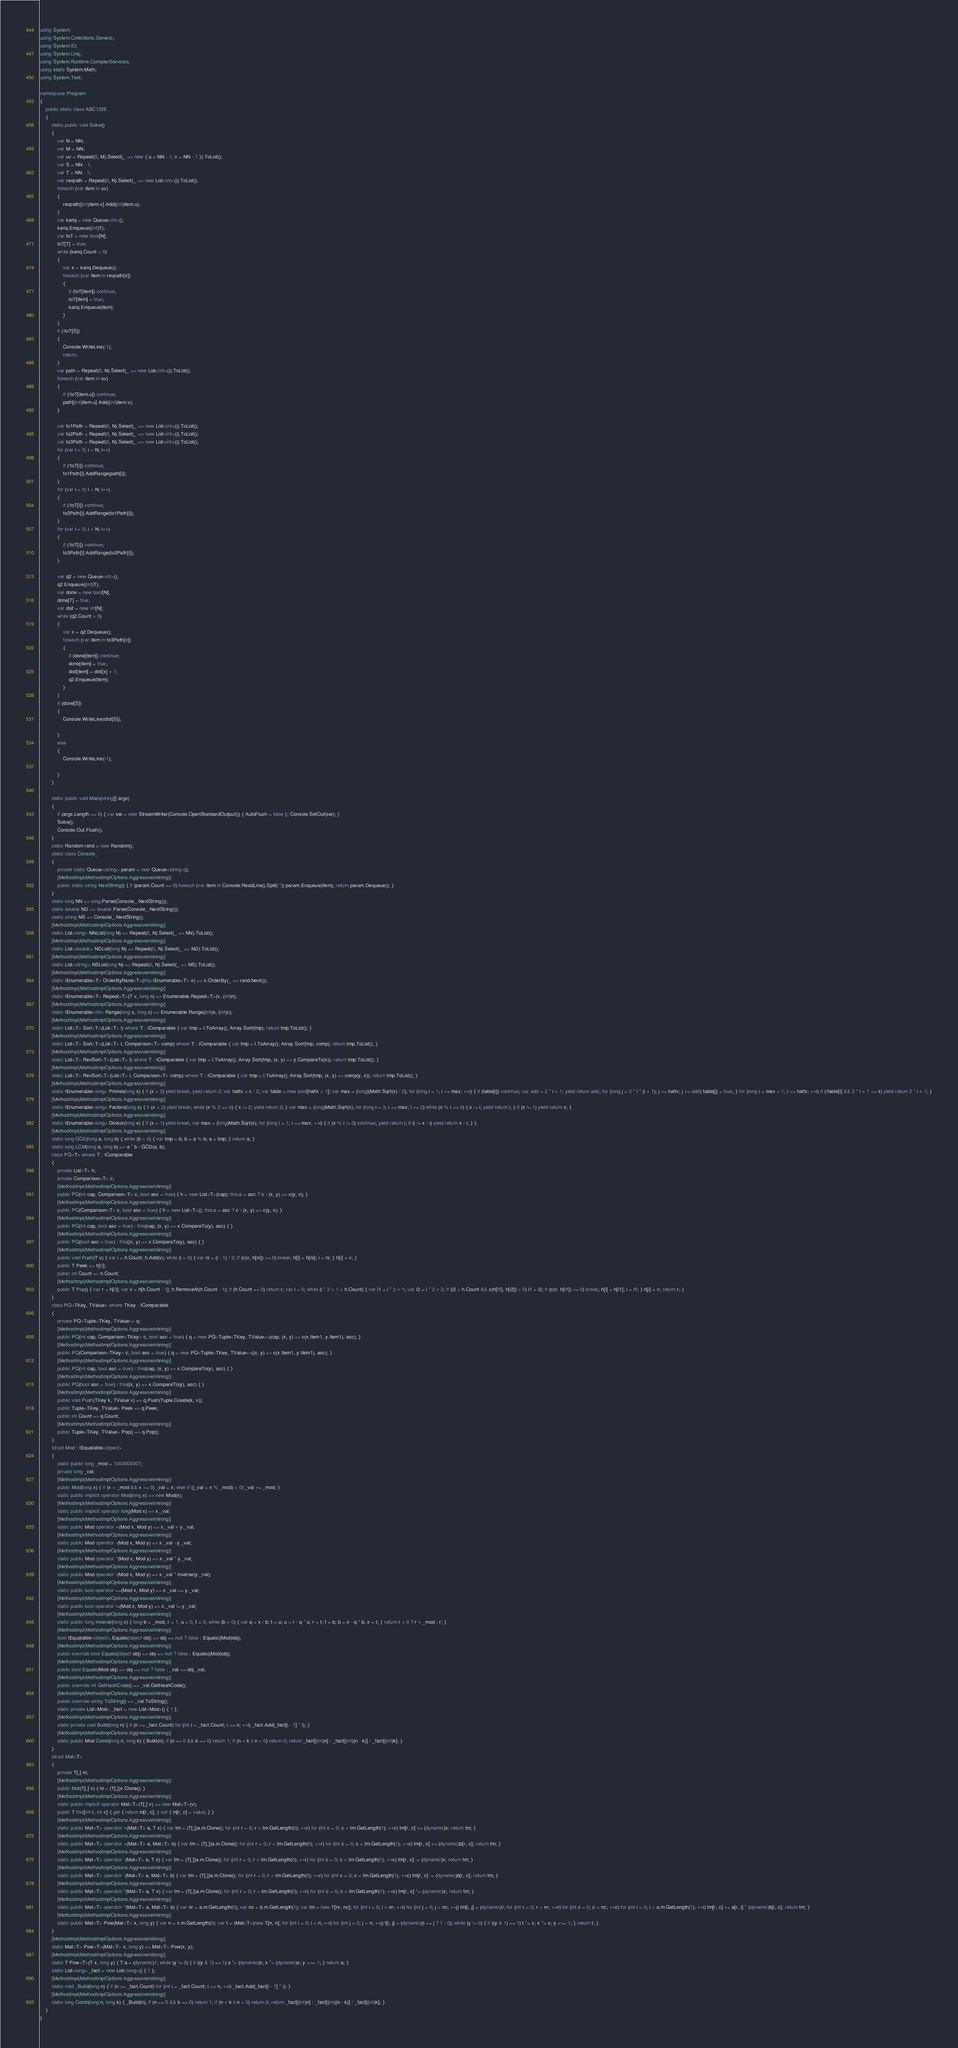<code> <loc_0><loc_0><loc_500><loc_500><_C#_>using System;
using System.Collections.Generic;
using System.IO;
using System.Linq;
using System.Runtime.CompilerServices;
using static System.Math;
using System.Text;

namespace Program
{
    public static class ABC132E
    {
        static public void Solve()
        {
            var N = NN;
            var M = NN;
            var uv = Repeat(0, M).Select(_ => new { u = NN - 1, v = NN - 1 }).ToList();
            var S = NN - 1;
            var T = NN - 1;
            var revpath = Repeat(0, N).Select(_ => new List<int>()).ToList();
            foreach (var item in uv)
            {
                revpath[(int)item.v].Add((int)item.u);
            }
            var kariq = new Queue<int>();
            kariq.Enqueue((int)T);
            var toT = new bool[N];
            toT[T] = true;
            while (kariq.Count > 0)
            {
                var x = kariq.Dequeue();
                foreach (var item in revpath[x])
                {
                    if (toT[item]) continue;
                    toT[item] = true;
                    kariq.Enqueue(item);
                }
            }
            if (!toT[S])
            {
                Console.WriteLine(-1);
                return;
            }
            var path = Repeat(0, N).Select(_ => new List<int>()).ToList();
            foreach (var item in uv)
            {
                if (!toT[item.u]) continue;
                path[(int)item.u].Add((int)item.v);
            }

            var to1Path = Repeat(0, N).Select(_ => new List<int>()).ToList();
            var to2Path = Repeat(0, N).Select(_ => new List<int>()).ToList();
            var to3Path = Repeat(0, N).Select(_ => new List<int>()).ToList();
            for (var i = 0; i < N; i++)
            {
                if (!toT[i]) continue;
                to1Path[i].AddRange(path[i]);
            }
            for (var i = 0; i < N; i++)
            {
                if (!toT[i]) continue;
                to2Path[i].AddRange(to1Path[i]);
            }
            for (var i = 0; i < N; i++)
            {
                if (!toT[i]) continue;
                to3Path[i].AddRange(to2Path[i]);
            }

            var q2 = new Queue<int>();
            q2.Enqueue((int)T);
            var done = new bool[N];
            done[T] = true;
            var dist = new int[N];
            while (q2.Count > 0)
            {
                var x = q2.Dequeue();
                foreach (var item in to3Path[x])
                {
                    if (done[item]) continue;
                    done[item] = true;
                    dist[item] = dist[x] + 1;
                    q2.Enqueue(item);
                }
            }
            if (done[S])
            {
                Console.WriteLine(dist[S]);

            }
            else
            {
                Console.WriteLine(-1);

            }
        }

        static public void Main(string[] args)
        {
            if (args.Length == 0) { var sw = new StreamWriter(Console.OpenStandardOutput()) { AutoFlush = false }; Console.SetOut(sw); }
            Solve();
            Console.Out.Flush();
        }
        static Random rand = new Random();
        static class Console_
        {
            private static Queue<string> param = new Queue<string>();
            [MethodImpl(MethodImplOptions.AggressiveInlining)]
            public static string NextString() { if (param.Count == 0) foreach (var item in Console.ReadLine().Split(' ')) param.Enqueue(item); return param.Dequeue(); }
        }
        static long NN => long.Parse(Console_.NextString());
        static double ND => double.Parse(Console_.NextString());
        static string NS => Console_.NextString();
        [MethodImpl(MethodImplOptions.AggressiveInlining)]
        static List<long> NNList(long N) => Repeat(0, N).Select(_ => NN).ToList();
        [MethodImpl(MethodImplOptions.AggressiveInlining)]
        static List<double> NDList(long N) => Repeat(0, N).Select(_ => ND).ToList();
        [MethodImpl(MethodImplOptions.AggressiveInlining)]
        static List<string> NSList(long N) => Repeat(0, N).Select(_ => NS).ToList();
        [MethodImpl(MethodImplOptions.AggressiveInlining)]
        static IEnumerable<T> OrderByRand<T>(this IEnumerable<T> x) => x.OrderBy(_ => rand.Next());
        [MethodImpl(MethodImplOptions.AggressiveInlining)]
        static IEnumerable<T> Repeat<T>(T v, long n) => Enumerable.Repeat<T>(v, (int)n);
        [MethodImpl(MethodImplOptions.AggressiveInlining)]
        static IEnumerable<int> Range(long s, long c) => Enumerable.Range((int)s, (int)c);
        [MethodImpl(MethodImplOptions.AggressiveInlining)]
        static List<T> Sort<T>(List<T> l) where T : IComparable { var tmp = l.ToArray(); Array.Sort(tmp); return tmp.ToList(); }
        [MethodImpl(MethodImplOptions.AggressiveInlining)]
        static List<T> Sort<T>(List<T> l, Comparison<T> comp) where T : IComparable { var tmp = l.ToArray(); Array.Sort(tmp, comp); return tmp.ToList(); }
        [MethodImpl(MethodImplOptions.AggressiveInlining)]
        static List<T> RevSort<T>(List<T> l) where T : IComparable { var tmp = l.ToArray(); Array.Sort(tmp, (x, y) => y.CompareTo(x)); return tmp.ToList(); }
        [MethodImpl(MethodImplOptions.AggressiveInlining)]
        static List<T> RevSort<T>(List<T> l, Comparison<T> comp) where T : IComparable { var tmp = l.ToArray(); Array.Sort(tmp, (x, y) => comp(y, x)); return tmp.ToList(); }
        [MethodImpl(MethodImplOptions.AggressiveInlining)]
        static IEnumerable<long> Primes(long x) { if (x < 2) yield break; yield return 2; var halfx = x / 2; var table = new bool[halfx + 1]; var max = (long)(Math.Sqrt(x) / 2); for (long i = 1; i <= max; ++i) { if (table[i]) continue; var add = 2 * i + 1; yield return add; for (long j = 2 * i * (i + 1); j <= halfx; j += add) table[j] = true; } for (long i = max + 1; i <= halfx; ++i) if (!table[i] && 2 * i + 1 <= x) yield return 2 * i + 1; }
        [MethodImpl(MethodImplOptions.AggressiveInlining)]
        static IEnumerable<long> Factors(long x) { if (x < 2) yield break; while (x % 2 == 0) { x /= 2; yield return 2; } var max = (long)Math.Sqrt(x); for (long i = 3; i <= max; i += 2) while (x % i == 0) { x /= i; yield return i; } if (x != 1) yield return x; }
        [MethodImpl(MethodImplOptions.AggressiveInlining)]
        static IEnumerable<long> Divisor(long x) { if (x < 1) yield break; var max = (long)Math.Sqrt(x); for (long i = 1; i <= max; ++i) { if (x % i != 0) continue; yield return i; if (i != x / i) yield return x / i; } }
        [MethodImpl(MethodImplOptions.AggressiveInlining)]
        static long GCD(long a, long b) { while (b > 0) { var tmp = b; b = a % b; a = tmp; } return a; }
        static long LCM(long a, long b) => a * b / GCD(a, b);
        class PQ<T> where T : IComparable
        {
            private List<T> h;
            private Comparison<T> c;
            [MethodImpl(MethodImplOptions.AggressiveInlining)]
            public PQ(int cap, Comparison<T> c, bool asc = true) { h = new List<T>(cap); this.c = asc ? c : (x, y) => c(y, x); }
            [MethodImpl(MethodImplOptions.AggressiveInlining)]
            public PQ(Comparison<T> c, bool asc = true) { h = new List<T>(); this.c = asc ? c : (x, y) => c(y, x); }
            [MethodImpl(MethodImplOptions.AggressiveInlining)]
            public PQ(int cap, bool asc = true) : this(cap, (x, y) => x.CompareTo(y), asc) { }
            [MethodImpl(MethodImplOptions.AggressiveInlining)]
            public PQ(bool asc = true) : this((x, y) => x.CompareTo(y), asc) { }
            [MethodImpl(MethodImplOptions.AggressiveInlining)]
            public void Push(T v) { var i = h.Count; h.Add(v); while (i > 0) { var ni = (i - 1) / 2; if (c(v, h[ni]) >= 0) break; h[i] = h[ni]; i = ni; } h[i] = v; }
            public T Peek => h[0];
            public int Count => h.Count;
            [MethodImpl(MethodImplOptions.AggressiveInlining)]
            public T Pop() { var r = h[0]; var v = h[h.Count - 1]; h.RemoveAt(h.Count - 1); if (h.Count == 0) return r; var i = 0; while (i * 2 + 1 < h.Count) { var i1 = i * 2 + 1; var i2 = i * 2 + 2; if (i2 < h.Count && c(h[i1], h[i2]) > 0) i1 = i2; if (c(v, h[i1]) <= 0) break; h[i] = h[i1]; i = i1; } h[i] = v; return r; }
        }
        class PQ<TKey, TValue> where TKey : IComparable
        {
            private PQ<Tuple<TKey, TValue>> q;
            [MethodImpl(MethodImplOptions.AggressiveInlining)]
            public PQ(int cap, Comparison<TKey> c, bool asc = true) { q = new PQ<Tuple<TKey, TValue>>(cap, (x, y) => c(x.Item1, y.Item1), asc); }
            [MethodImpl(MethodImplOptions.AggressiveInlining)]
            public PQ(Comparison<TKey> c, bool asc = true) { q = new PQ<Tuple<TKey, TValue>>((x, y) => c(x.Item1, y.Item1), asc); }
            [MethodImpl(MethodImplOptions.AggressiveInlining)]
            public PQ(int cap, bool asc = true) : this(cap, (x, y) => x.CompareTo(y), asc) { }
            [MethodImpl(MethodImplOptions.AggressiveInlining)]
            public PQ(bool asc = true) : this((x, y) => x.CompareTo(y), asc) { }
            [MethodImpl(MethodImplOptions.AggressiveInlining)]
            public void Push(TKey k, TValue v) => q.Push(Tuple.Create(k, v));
            public Tuple<TKey, TValue> Peek => q.Peek;
            public int Count => q.Count;
            [MethodImpl(MethodImplOptions.AggressiveInlining)]
            public Tuple<TKey, TValue> Pop() => q.Pop();
        }
        struct Mod : IEquatable<object>
        {
            static public long _mod = 1000000007;
            private long _val;
            [MethodImpl(MethodImplOptions.AggressiveInlining)]
            public Mod(long x) { if (x < _mod && x >= 0) _val = x; else if ((_val = x % _mod) < 0) _val += _mod; }
            static public implicit operator Mod(long x) => new Mod(x);
            [MethodImpl(MethodImplOptions.AggressiveInlining)]
            static public implicit operator long(Mod x) => x._val;
            [MethodImpl(MethodImplOptions.AggressiveInlining)]
            static public Mod operator +(Mod x, Mod y) => x._val + y._val;
            [MethodImpl(MethodImplOptions.AggressiveInlining)]
            static public Mod operator -(Mod x, Mod y) => x._val - y._val;
            [MethodImpl(MethodImplOptions.AggressiveInlining)]
            static public Mod operator *(Mod x, Mod y) => x._val * y._val;
            [MethodImpl(MethodImplOptions.AggressiveInlining)]
            static public Mod operator /(Mod x, Mod y) => x._val * Inverse(y._val);
            [MethodImpl(MethodImplOptions.AggressiveInlining)]
            static public bool operator ==(Mod x, Mod y) => x._val == y._val;
            [MethodImpl(MethodImplOptions.AggressiveInlining)]
            static public bool operator !=(Mod x, Mod y) => x._val != y._val;
            [MethodImpl(MethodImplOptions.AggressiveInlining)]
            static public long Inverse(long x) { long b = _mod, r = 1, u = 0, t = 0; while (b > 0) { var q = x / b; t = u; u = r - q * u; r = t; t = b; b = x - q * b; x = t; } return r < 0 ? r + _mod : r; }
            [MethodImpl(MethodImplOptions.AggressiveInlining)]
            bool IEquatable<object>.Equals(object obj) => obj == null ? false : Equals((Mod)obj);
            [MethodImpl(MethodImplOptions.AggressiveInlining)]
            public override bool Equals(object obj) => obj == null ? false : Equals((Mod)obj);
            [MethodImpl(MethodImplOptions.AggressiveInlining)]
            public bool Equals(Mod obj) => obj == null ? false : _val == obj._val;
            [MethodImpl(MethodImplOptions.AggressiveInlining)]
            public override int GetHashCode() => _val.GetHashCode();
            [MethodImpl(MethodImplOptions.AggressiveInlining)]
            public override string ToString() => _val.ToString();
            static private List<Mod> _fact = new List<Mod>() { 1 };
            [MethodImpl(MethodImplOptions.AggressiveInlining)]
            static private void Build(long n) { if (n >= _fact.Count) for (int i = _fact.Count; i <= n; ++i) _fact.Add(_fact[i - 1] * i); }
            [MethodImpl(MethodImplOptions.AggressiveInlining)]
            static public Mod Comb(long n, long k) { Build(n); if (n == 0 && k == 0) return 1; if (n < k || n < 0) return 0; return _fact[(int)n] / _fact[(int)(n - k)] / _fact[(int)k]; }
        }
        struct Mat<T>
        {
            private T[,] m;
            [MethodImpl(MethodImplOptions.AggressiveInlining)]
            public Mat(T[,] v) { m = (T[,])v.Clone(); }
            [MethodImpl(MethodImplOptions.AggressiveInlining)]
            static public implicit operator Mat<T>(T[,] v) => new Mat<T>(v);
            public T this[int r, int c] { get { return m[r, c]; } set { m[r, c] = value; } }
            [MethodImpl(MethodImplOptions.AggressiveInlining)]
            static public Mat<T> operator +(Mat<T> a, T x) { var tm = (T[,])a.m.Clone(); for (int r = 0; r < tm.GetLength(0); ++r) for (int c = 0; c < tm.GetLength(1); ++c) tm[r, c] += (dynamic)x; return tm; }
            [MethodImpl(MethodImplOptions.AggressiveInlining)]
            static public Mat<T> operator +(Mat<T> a, Mat<T> b) { var tm = (T[,])a.m.Clone(); for (int r = 0; r < tm.GetLength(0); ++r) for (int c = 0; c < tm.GetLength(1); ++c) tm[r, c] += (dynamic)b[r, c]; return tm; }
            [MethodImpl(MethodImplOptions.AggressiveInlining)]
            static public Mat<T> operator -(Mat<T> a, T x) { var tm = (T[,])a.m.Clone(); for (int r = 0; r < tm.GetLength(0); ++r) for (int c = 0; c < tm.GetLength(1); ++c) tm[r, c] -= (dynamic)x; return tm; }
            [MethodImpl(MethodImplOptions.AggressiveInlining)]
            static public Mat<T> operator -(Mat<T> a, Mat<T> b) { var tm = (T[,])a.m.Clone(); for (int r = 0; r < tm.GetLength(0); ++r) for (int c = 0; c < tm.GetLength(1); ++c) tm[r, c] -= (dynamic)b[r, c]; return tm; }
            [MethodImpl(MethodImplOptions.AggressiveInlining)]
            static public Mat<T> operator *(Mat<T> a, T x) { var tm = (T[,])a.m.Clone(); for (int r = 0; r < tm.GetLength(0); ++r) for (int c = 0; c < tm.GetLength(1); ++c) tm[r, c] *= (dynamic)x; return tm; }
            [MethodImpl(MethodImplOptions.AggressiveInlining)]
            static public Mat<T> operator *(Mat<T> a, Mat<T> b) { var nr = a.m.GetLength(0); var nc = b.m.GetLength(1); var tm = new T[nr, nc]; for (int i = 0; i < nr; ++i) for (int j = 0; j < nc; ++j) tm[i, j] = (dynamic)0; for (int r = 0; r < nr; ++r) for (int c = 0; c < nc; ++c) for (int i = 0; i < a.m.GetLength(1); ++i) tm[r, c] += a[r, i] * (dynamic)b[i, c]; return tm; }
            [MethodImpl(MethodImplOptions.AggressiveInlining)]
            static public Mat<T> Pow(Mat<T> x, long y) { var n = x.m.GetLength(0); var t = (Mat<T>)new T[n, n]; for (int i = 0; i < n; ++i) for (int j = 0; j < n; ++j) t[i, j] = (dynamic)(i == j ? 1 : 0); while (y != 0) { if ((y & 1) == 1) t *= x; x *= x; y >>= 1; } return t; }
        }
        [MethodImpl(MethodImplOptions.AggressiveInlining)]
        static Mat<T> Pow<T>(Mat<T> x, long y) => Mat<T>.Pow(x, y);
        [MethodImpl(MethodImplOptions.AggressiveInlining)]
        static T Pow<T>(T x, long y) { T a = (dynamic)1; while (y != 0) { if ((y & 1) == 1) a *= (dynamic)x; x *= (dynamic)x; y >>= 1; } return a; }
        static List<long> _fact = new List<long>() { 1 };
        [MethodImpl(MethodImplOptions.AggressiveInlining)]
        static void _Build(long n) { if (n >= _fact.Count) for (int i = _fact.Count; i <= n; ++i) _fact.Add(_fact[i - 1] * i); }
        [MethodImpl(MethodImplOptions.AggressiveInlining)]
        static long Comb(long n, long k) { _Build(n); if (n == 0 && k == 0) return 1; if (n < k || n < 0) return 0; return _fact[(int)n] / _fact[(int)(n - k)] / _fact[(int)k]; }
    }
}
</code> 